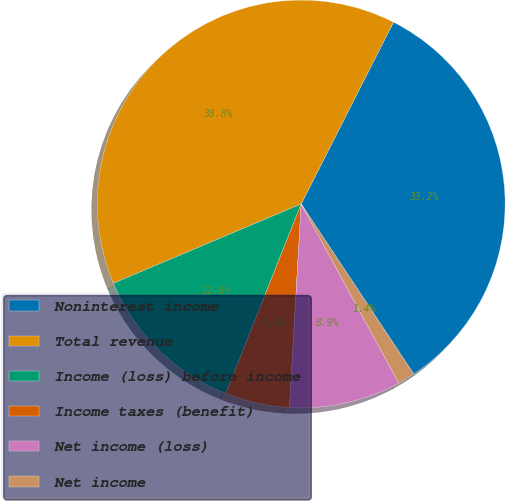Convert chart to OTSL. <chart><loc_0><loc_0><loc_500><loc_500><pie_chart><fcel>Noninterest income<fcel>Total revenue<fcel>Income (loss) before income<fcel>Income taxes (benefit)<fcel>Net income (loss)<fcel>Net income<nl><fcel>33.22%<fcel>38.84%<fcel>12.61%<fcel>5.11%<fcel>8.86%<fcel>1.36%<nl></chart> 